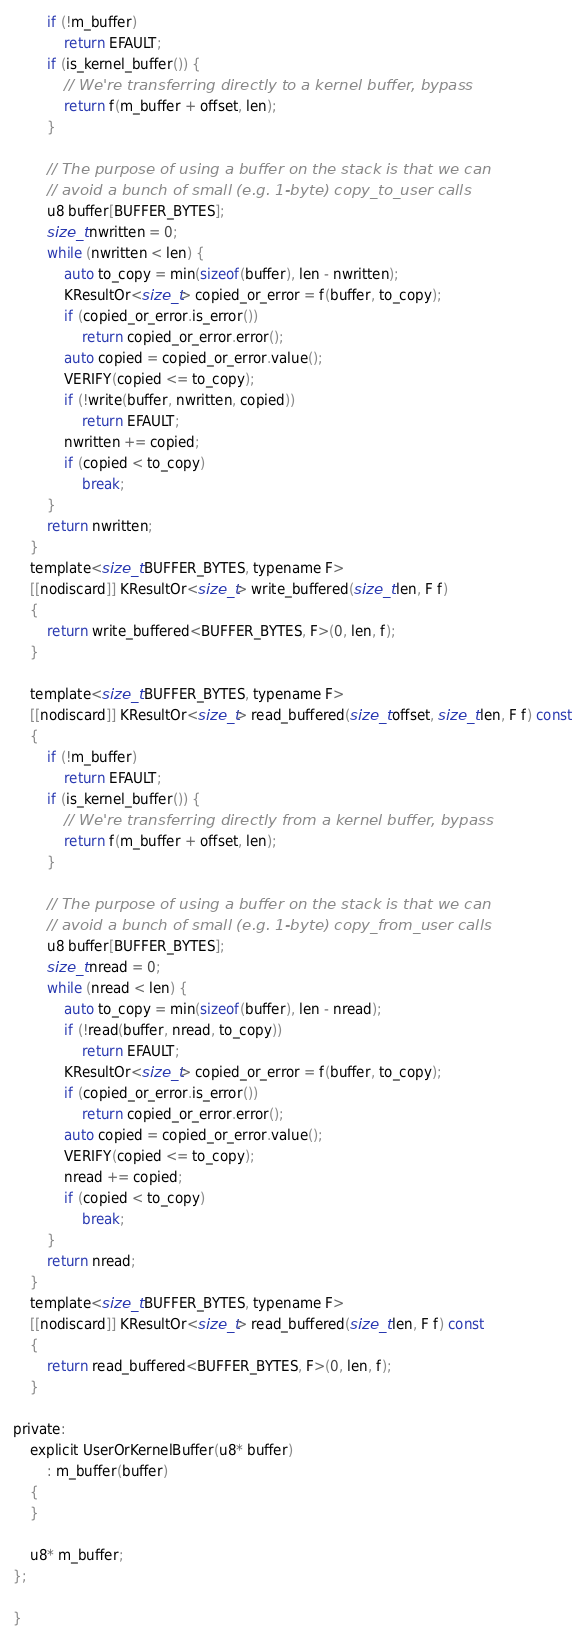Convert code to text. <code><loc_0><loc_0><loc_500><loc_500><_C_>        if (!m_buffer)
            return EFAULT;
        if (is_kernel_buffer()) {
            // We're transferring directly to a kernel buffer, bypass
            return f(m_buffer + offset, len);
        }

        // The purpose of using a buffer on the stack is that we can
        // avoid a bunch of small (e.g. 1-byte) copy_to_user calls
        u8 buffer[BUFFER_BYTES];
        size_t nwritten = 0;
        while (nwritten < len) {
            auto to_copy = min(sizeof(buffer), len - nwritten);
            KResultOr<size_t> copied_or_error = f(buffer, to_copy);
            if (copied_or_error.is_error())
                return copied_or_error.error();
            auto copied = copied_or_error.value();
            VERIFY(copied <= to_copy);
            if (!write(buffer, nwritten, copied))
                return EFAULT;
            nwritten += copied;
            if (copied < to_copy)
                break;
        }
        return nwritten;
    }
    template<size_t BUFFER_BYTES, typename F>
    [[nodiscard]] KResultOr<size_t> write_buffered(size_t len, F f)
    {
        return write_buffered<BUFFER_BYTES, F>(0, len, f);
    }

    template<size_t BUFFER_BYTES, typename F>
    [[nodiscard]] KResultOr<size_t> read_buffered(size_t offset, size_t len, F f) const
    {
        if (!m_buffer)
            return EFAULT;
        if (is_kernel_buffer()) {
            // We're transferring directly from a kernel buffer, bypass
            return f(m_buffer + offset, len);
        }

        // The purpose of using a buffer on the stack is that we can
        // avoid a bunch of small (e.g. 1-byte) copy_from_user calls
        u8 buffer[BUFFER_BYTES];
        size_t nread = 0;
        while (nread < len) {
            auto to_copy = min(sizeof(buffer), len - nread);
            if (!read(buffer, nread, to_copy))
                return EFAULT;
            KResultOr<size_t> copied_or_error = f(buffer, to_copy);
            if (copied_or_error.is_error())
                return copied_or_error.error();
            auto copied = copied_or_error.value();
            VERIFY(copied <= to_copy);
            nread += copied;
            if (copied < to_copy)
                break;
        }
        return nread;
    }
    template<size_t BUFFER_BYTES, typename F>
    [[nodiscard]] KResultOr<size_t> read_buffered(size_t len, F f) const
    {
        return read_buffered<BUFFER_BYTES, F>(0, len, f);
    }

private:
    explicit UserOrKernelBuffer(u8* buffer)
        : m_buffer(buffer)
    {
    }

    u8* m_buffer;
};

}
</code> 